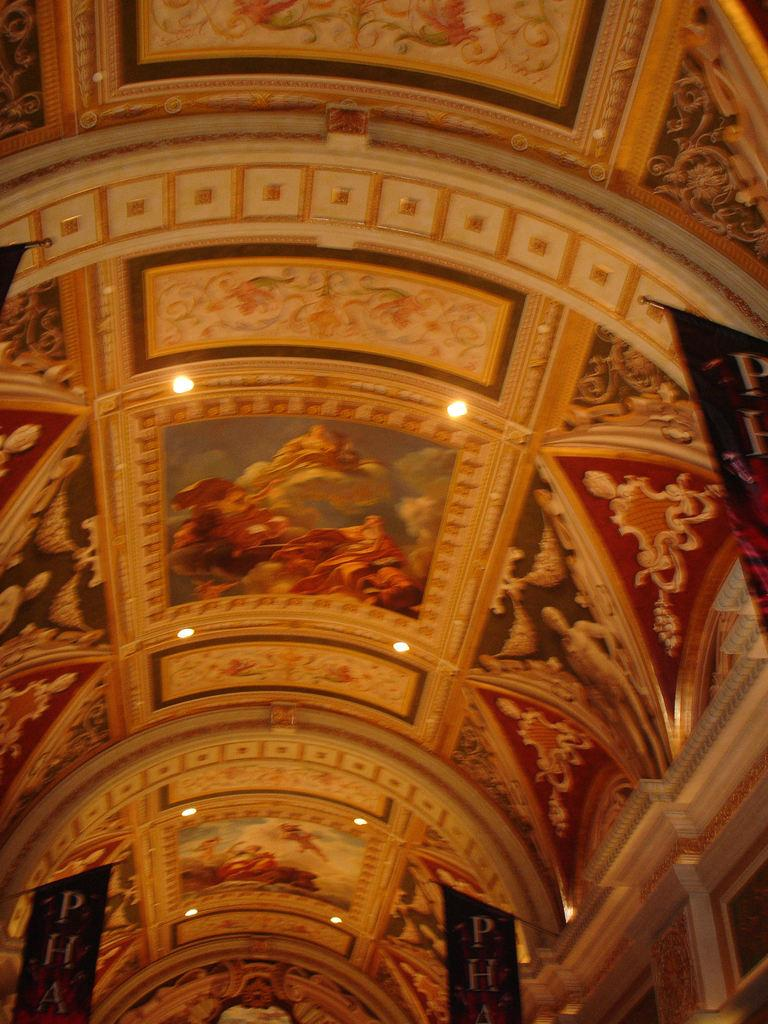Where is the image taken? The image is inside a building. What can be seen on the wall in the image? There are lights and paintings on the wall in the image. Can you describe the art on the wall? There is some art on the wall, which includes paintings. What type of weather can be seen through the window in the image? There is no window present in the image, so it is not possible to determine the weather. 